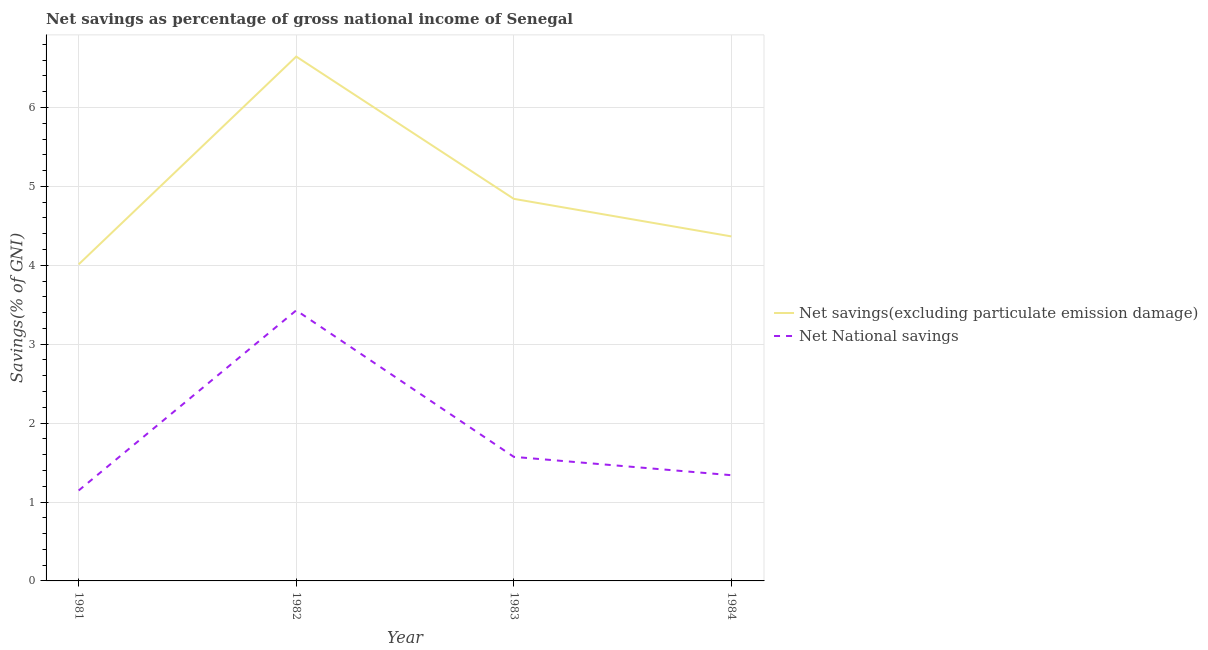How many different coloured lines are there?
Offer a terse response. 2. Does the line corresponding to net national savings intersect with the line corresponding to net savings(excluding particulate emission damage)?
Provide a succinct answer. No. Is the number of lines equal to the number of legend labels?
Keep it short and to the point. Yes. What is the net national savings in 1984?
Your answer should be compact. 1.34. Across all years, what is the maximum net savings(excluding particulate emission damage)?
Your response must be concise. 6.65. Across all years, what is the minimum net national savings?
Keep it short and to the point. 1.15. In which year was the net savings(excluding particulate emission damage) maximum?
Keep it short and to the point. 1982. In which year was the net national savings minimum?
Make the answer very short. 1981. What is the total net savings(excluding particulate emission damage) in the graph?
Your answer should be very brief. 19.87. What is the difference between the net national savings in 1981 and that in 1984?
Offer a terse response. -0.19. What is the difference between the net national savings in 1981 and the net savings(excluding particulate emission damage) in 1984?
Your response must be concise. -3.22. What is the average net national savings per year?
Offer a terse response. 1.87. In the year 1984, what is the difference between the net national savings and net savings(excluding particulate emission damage)?
Provide a short and direct response. -3.03. In how many years, is the net savings(excluding particulate emission damage) greater than 3.2 %?
Give a very brief answer. 4. What is the ratio of the net national savings in 1981 to that in 1984?
Your answer should be compact. 0.86. Is the difference between the net national savings in 1982 and 1984 greater than the difference between the net savings(excluding particulate emission damage) in 1982 and 1984?
Make the answer very short. No. What is the difference between the highest and the second highest net national savings?
Your response must be concise. 1.86. What is the difference between the highest and the lowest net savings(excluding particulate emission damage)?
Provide a short and direct response. 2.63. In how many years, is the net savings(excluding particulate emission damage) greater than the average net savings(excluding particulate emission damage) taken over all years?
Your answer should be very brief. 1. Is the sum of the net national savings in 1982 and 1983 greater than the maximum net savings(excluding particulate emission damage) across all years?
Make the answer very short. No. Does the net savings(excluding particulate emission damage) monotonically increase over the years?
Your answer should be compact. No. Is the net savings(excluding particulate emission damage) strictly greater than the net national savings over the years?
Your response must be concise. Yes. Is the net savings(excluding particulate emission damage) strictly less than the net national savings over the years?
Your answer should be very brief. No. Are the values on the major ticks of Y-axis written in scientific E-notation?
Keep it short and to the point. No. Does the graph contain any zero values?
Your response must be concise. No. How many legend labels are there?
Your answer should be compact. 2. What is the title of the graph?
Provide a succinct answer. Net savings as percentage of gross national income of Senegal. What is the label or title of the Y-axis?
Your response must be concise. Savings(% of GNI). What is the Savings(% of GNI) of Net savings(excluding particulate emission damage) in 1981?
Give a very brief answer. 4.01. What is the Savings(% of GNI) of Net National savings in 1981?
Provide a succinct answer. 1.15. What is the Savings(% of GNI) in Net savings(excluding particulate emission damage) in 1982?
Provide a succinct answer. 6.65. What is the Savings(% of GNI) of Net National savings in 1982?
Offer a very short reply. 3.43. What is the Savings(% of GNI) in Net savings(excluding particulate emission damage) in 1983?
Your response must be concise. 4.84. What is the Savings(% of GNI) in Net National savings in 1983?
Your answer should be very brief. 1.57. What is the Savings(% of GNI) in Net savings(excluding particulate emission damage) in 1984?
Offer a very short reply. 4.37. What is the Savings(% of GNI) of Net National savings in 1984?
Keep it short and to the point. 1.34. Across all years, what is the maximum Savings(% of GNI) in Net savings(excluding particulate emission damage)?
Your response must be concise. 6.65. Across all years, what is the maximum Savings(% of GNI) in Net National savings?
Provide a succinct answer. 3.43. Across all years, what is the minimum Savings(% of GNI) of Net savings(excluding particulate emission damage)?
Offer a terse response. 4.01. Across all years, what is the minimum Savings(% of GNI) of Net National savings?
Your answer should be compact. 1.15. What is the total Savings(% of GNI) in Net savings(excluding particulate emission damage) in the graph?
Offer a terse response. 19.87. What is the total Savings(% of GNI) of Net National savings in the graph?
Your answer should be very brief. 7.49. What is the difference between the Savings(% of GNI) of Net savings(excluding particulate emission damage) in 1981 and that in 1982?
Provide a succinct answer. -2.63. What is the difference between the Savings(% of GNI) of Net National savings in 1981 and that in 1982?
Offer a terse response. -2.28. What is the difference between the Savings(% of GNI) of Net savings(excluding particulate emission damage) in 1981 and that in 1983?
Offer a terse response. -0.83. What is the difference between the Savings(% of GNI) of Net National savings in 1981 and that in 1983?
Provide a succinct answer. -0.43. What is the difference between the Savings(% of GNI) of Net savings(excluding particulate emission damage) in 1981 and that in 1984?
Provide a succinct answer. -0.35. What is the difference between the Savings(% of GNI) in Net National savings in 1981 and that in 1984?
Keep it short and to the point. -0.19. What is the difference between the Savings(% of GNI) of Net savings(excluding particulate emission damage) in 1982 and that in 1983?
Offer a terse response. 1.8. What is the difference between the Savings(% of GNI) in Net National savings in 1982 and that in 1983?
Give a very brief answer. 1.86. What is the difference between the Savings(% of GNI) of Net savings(excluding particulate emission damage) in 1982 and that in 1984?
Make the answer very short. 2.28. What is the difference between the Savings(% of GNI) of Net National savings in 1982 and that in 1984?
Your answer should be very brief. 2.09. What is the difference between the Savings(% of GNI) of Net savings(excluding particulate emission damage) in 1983 and that in 1984?
Make the answer very short. 0.48. What is the difference between the Savings(% of GNI) in Net National savings in 1983 and that in 1984?
Provide a short and direct response. 0.23. What is the difference between the Savings(% of GNI) of Net savings(excluding particulate emission damage) in 1981 and the Savings(% of GNI) of Net National savings in 1982?
Provide a succinct answer. 0.58. What is the difference between the Savings(% of GNI) of Net savings(excluding particulate emission damage) in 1981 and the Savings(% of GNI) of Net National savings in 1983?
Provide a short and direct response. 2.44. What is the difference between the Savings(% of GNI) in Net savings(excluding particulate emission damage) in 1981 and the Savings(% of GNI) in Net National savings in 1984?
Your response must be concise. 2.67. What is the difference between the Savings(% of GNI) in Net savings(excluding particulate emission damage) in 1982 and the Savings(% of GNI) in Net National savings in 1983?
Keep it short and to the point. 5.07. What is the difference between the Savings(% of GNI) in Net savings(excluding particulate emission damage) in 1982 and the Savings(% of GNI) in Net National savings in 1984?
Make the answer very short. 5.31. What is the difference between the Savings(% of GNI) of Net savings(excluding particulate emission damage) in 1983 and the Savings(% of GNI) of Net National savings in 1984?
Your response must be concise. 3.5. What is the average Savings(% of GNI) of Net savings(excluding particulate emission damage) per year?
Make the answer very short. 4.97. What is the average Savings(% of GNI) in Net National savings per year?
Give a very brief answer. 1.87. In the year 1981, what is the difference between the Savings(% of GNI) in Net savings(excluding particulate emission damage) and Savings(% of GNI) in Net National savings?
Provide a succinct answer. 2.87. In the year 1982, what is the difference between the Savings(% of GNI) of Net savings(excluding particulate emission damage) and Savings(% of GNI) of Net National savings?
Your answer should be very brief. 3.22. In the year 1983, what is the difference between the Savings(% of GNI) of Net savings(excluding particulate emission damage) and Savings(% of GNI) of Net National savings?
Ensure brevity in your answer.  3.27. In the year 1984, what is the difference between the Savings(% of GNI) in Net savings(excluding particulate emission damage) and Savings(% of GNI) in Net National savings?
Your answer should be compact. 3.03. What is the ratio of the Savings(% of GNI) in Net savings(excluding particulate emission damage) in 1981 to that in 1982?
Your answer should be very brief. 0.6. What is the ratio of the Savings(% of GNI) in Net National savings in 1981 to that in 1982?
Your answer should be very brief. 0.33. What is the ratio of the Savings(% of GNI) in Net savings(excluding particulate emission damage) in 1981 to that in 1983?
Provide a succinct answer. 0.83. What is the ratio of the Savings(% of GNI) of Net National savings in 1981 to that in 1983?
Make the answer very short. 0.73. What is the ratio of the Savings(% of GNI) of Net savings(excluding particulate emission damage) in 1981 to that in 1984?
Your answer should be compact. 0.92. What is the ratio of the Savings(% of GNI) in Net National savings in 1981 to that in 1984?
Offer a terse response. 0.86. What is the ratio of the Savings(% of GNI) in Net savings(excluding particulate emission damage) in 1982 to that in 1983?
Give a very brief answer. 1.37. What is the ratio of the Savings(% of GNI) in Net National savings in 1982 to that in 1983?
Provide a succinct answer. 2.18. What is the ratio of the Savings(% of GNI) in Net savings(excluding particulate emission damage) in 1982 to that in 1984?
Provide a succinct answer. 1.52. What is the ratio of the Savings(% of GNI) in Net National savings in 1982 to that in 1984?
Offer a terse response. 2.56. What is the ratio of the Savings(% of GNI) in Net savings(excluding particulate emission damage) in 1983 to that in 1984?
Your answer should be very brief. 1.11. What is the ratio of the Savings(% of GNI) in Net National savings in 1983 to that in 1984?
Ensure brevity in your answer.  1.17. What is the difference between the highest and the second highest Savings(% of GNI) of Net savings(excluding particulate emission damage)?
Your answer should be very brief. 1.8. What is the difference between the highest and the second highest Savings(% of GNI) of Net National savings?
Make the answer very short. 1.86. What is the difference between the highest and the lowest Savings(% of GNI) of Net savings(excluding particulate emission damage)?
Make the answer very short. 2.63. What is the difference between the highest and the lowest Savings(% of GNI) in Net National savings?
Provide a short and direct response. 2.28. 